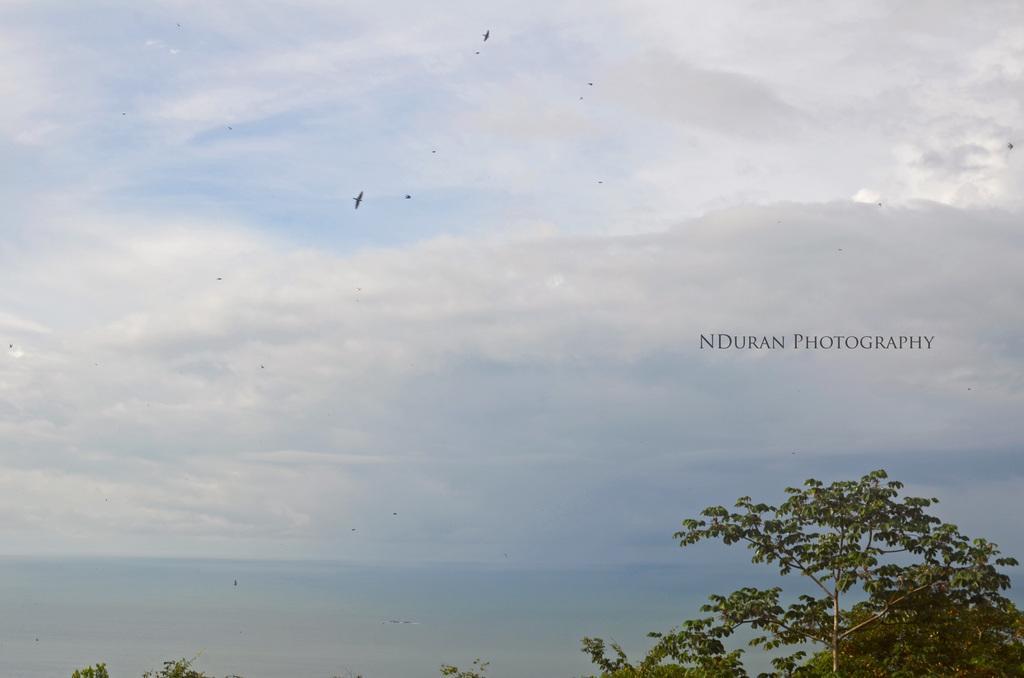Describe this image in one or two sentences. In this picture we can see trees and in the background we can see the sky with clouds. 